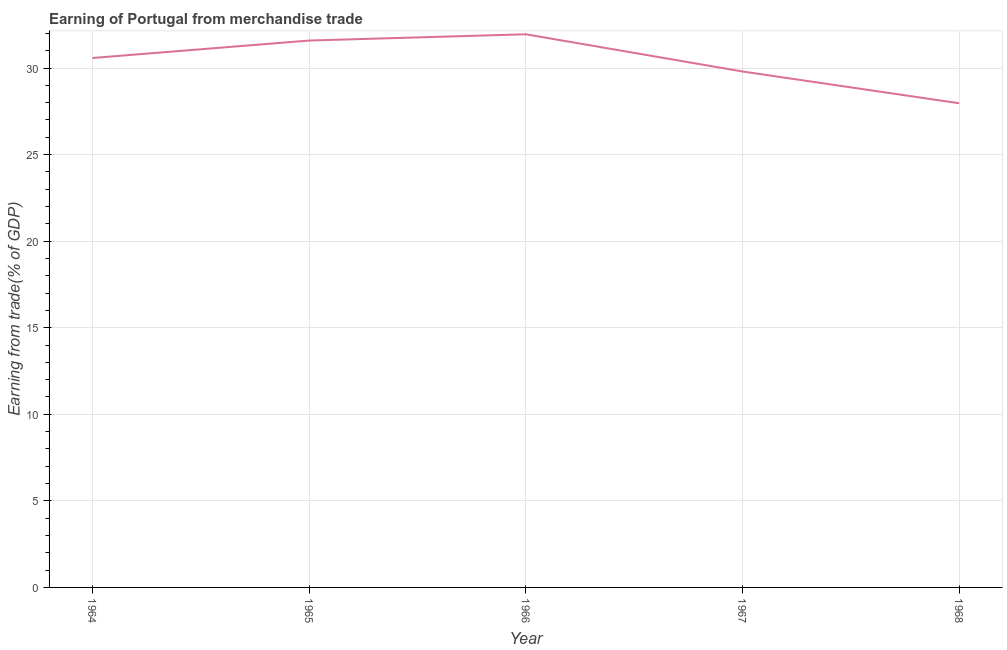What is the earning from merchandise trade in 1966?
Give a very brief answer. 31.95. Across all years, what is the maximum earning from merchandise trade?
Make the answer very short. 31.95. Across all years, what is the minimum earning from merchandise trade?
Your answer should be very brief. 27.97. In which year was the earning from merchandise trade maximum?
Your response must be concise. 1966. In which year was the earning from merchandise trade minimum?
Give a very brief answer. 1968. What is the sum of the earning from merchandise trade?
Ensure brevity in your answer.  151.88. What is the difference between the earning from merchandise trade in 1964 and 1968?
Make the answer very short. 2.61. What is the average earning from merchandise trade per year?
Your answer should be very brief. 30.38. What is the median earning from merchandise trade?
Keep it short and to the point. 30.58. What is the ratio of the earning from merchandise trade in 1967 to that in 1968?
Ensure brevity in your answer.  1.07. What is the difference between the highest and the second highest earning from merchandise trade?
Make the answer very short. 0.36. Is the sum of the earning from merchandise trade in 1966 and 1968 greater than the maximum earning from merchandise trade across all years?
Provide a short and direct response. Yes. What is the difference between the highest and the lowest earning from merchandise trade?
Ensure brevity in your answer.  3.98. Does the earning from merchandise trade monotonically increase over the years?
Your answer should be compact. No. How many lines are there?
Ensure brevity in your answer.  1. What is the difference between two consecutive major ticks on the Y-axis?
Ensure brevity in your answer.  5. Are the values on the major ticks of Y-axis written in scientific E-notation?
Keep it short and to the point. No. Does the graph contain any zero values?
Your answer should be compact. No. What is the title of the graph?
Your response must be concise. Earning of Portugal from merchandise trade. What is the label or title of the X-axis?
Your answer should be very brief. Year. What is the label or title of the Y-axis?
Provide a succinct answer. Earning from trade(% of GDP). What is the Earning from trade(% of GDP) in 1964?
Keep it short and to the point. 30.58. What is the Earning from trade(% of GDP) of 1965?
Ensure brevity in your answer.  31.59. What is the Earning from trade(% of GDP) in 1966?
Your response must be concise. 31.95. What is the Earning from trade(% of GDP) in 1967?
Your response must be concise. 29.8. What is the Earning from trade(% of GDP) in 1968?
Keep it short and to the point. 27.97. What is the difference between the Earning from trade(% of GDP) in 1964 and 1965?
Your answer should be compact. -1.01. What is the difference between the Earning from trade(% of GDP) in 1964 and 1966?
Provide a succinct answer. -1.37. What is the difference between the Earning from trade(% of GDP) in 1964 and 1967?
Offer a terse response. 0.78. What is the difference between the Earning from trade(% of GDP) in 1964 and 1968?
Provide a succinct answer. 2.61. What is the difference between the Earning from trade(% of GDP) in 1965 and 1966?
Make the answer very short. -0.36. What is the difference between the Earning from trade(% of GDP) in 1965 and 1967?
Provide a short and direct response. 1.79. What is the difference between the Earning from trade(% of GDP) in 1965 and 1968?
Give a very brief answer. 3.62. What is the difference between the Earning from trade(% of GDP) in 1966 and 1967?
Provide a succinct answer. 2.15. What is the difference between the Earning from trade(% of GDP) in 1966 and 1968?
Provide a short and direct response. 3.98. What is the difference between the Earning from trade(% of GDP) in 1967 and 1968?
Keep it short and to the point. 1.84. What is the ratio of the Earning from trade(% of GDP) in 1964 to that in 1965?
Provide a succinct answer. 0.97. What is the ratio of the Earning from trade(% of GDP) in 1964 to that in 1966?
Offer a terse response. 0.96. What is the ratio of the Earning from trade(% of GDP) in 1964 to that in 1967?
Offer a terse response. 1.03. What is the ratio of the Earning from trade(% of GDP) in 1964 to that in 1968?
Provide a succinct answer. 1.09. What is the ratio of the Earning from trade(% of GDP) in 1965 to that in 1967?
Provide a succinct answer. 1.06. What is the ratio of the Earning from trade(% of GDP) in 1965 to that in 1968?
Ensure brevity in your answer.  1.13. What is the ratio of the Earning from trade(% of GDP) in 1966 to that in 1967?
Offer a terse response. 1.07. What is the ratio of the Earning from trade(% of GDP) in 1966 to that in 1968?
Provide a succinct answer. 1.14. What is the ratio of the Earning from trade(% of GDP) in 1967 to that in 1968?
Your answer should be very brief. 1.07. 